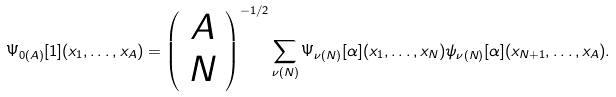<formula> <loc_0><loc_0><loc_500><loc_500>\Psi _ { 0 ( A ) } [ 1 ] ( x _ { 1 } , \dots , x _ { A } ) = { \left ( \begin{array} { c } A \\ N \end{array} \right ) } ^ { - 1 / 2 } \sum _ { \nu ( N ) } \Psi _ { \nu ( N ) } [ \alpha ] ( x _ { 1 } , \dots , x _ { N } ) \psi _ { \nu ( N ) } [ \alpha ] ( x _ { N + 1 } , \dots , x _ { A } ) .</formula> 